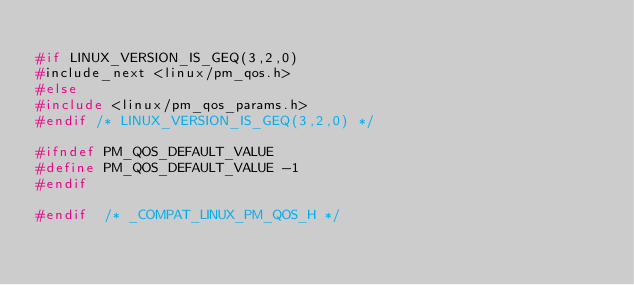<code> <loc_0><loc_0><loc_500><loc_500><_C_>
#if LINUX_VERSION_IS_GEQ(3,2,0)
#include_next <linux/pm_qos.h>
#else
#include <linux/pm_qos_params.h>
#endif /* LINUX_VERSION_IS_GEQ(3,2,0) */

#ifndef PM_QOS_DEFAULT_VALUE
#define PM_QOS_DEFAULT_VALUE -1
#endif

#endif	/* _COMPAT_LINUX_PM_QOS_H */
</code> 